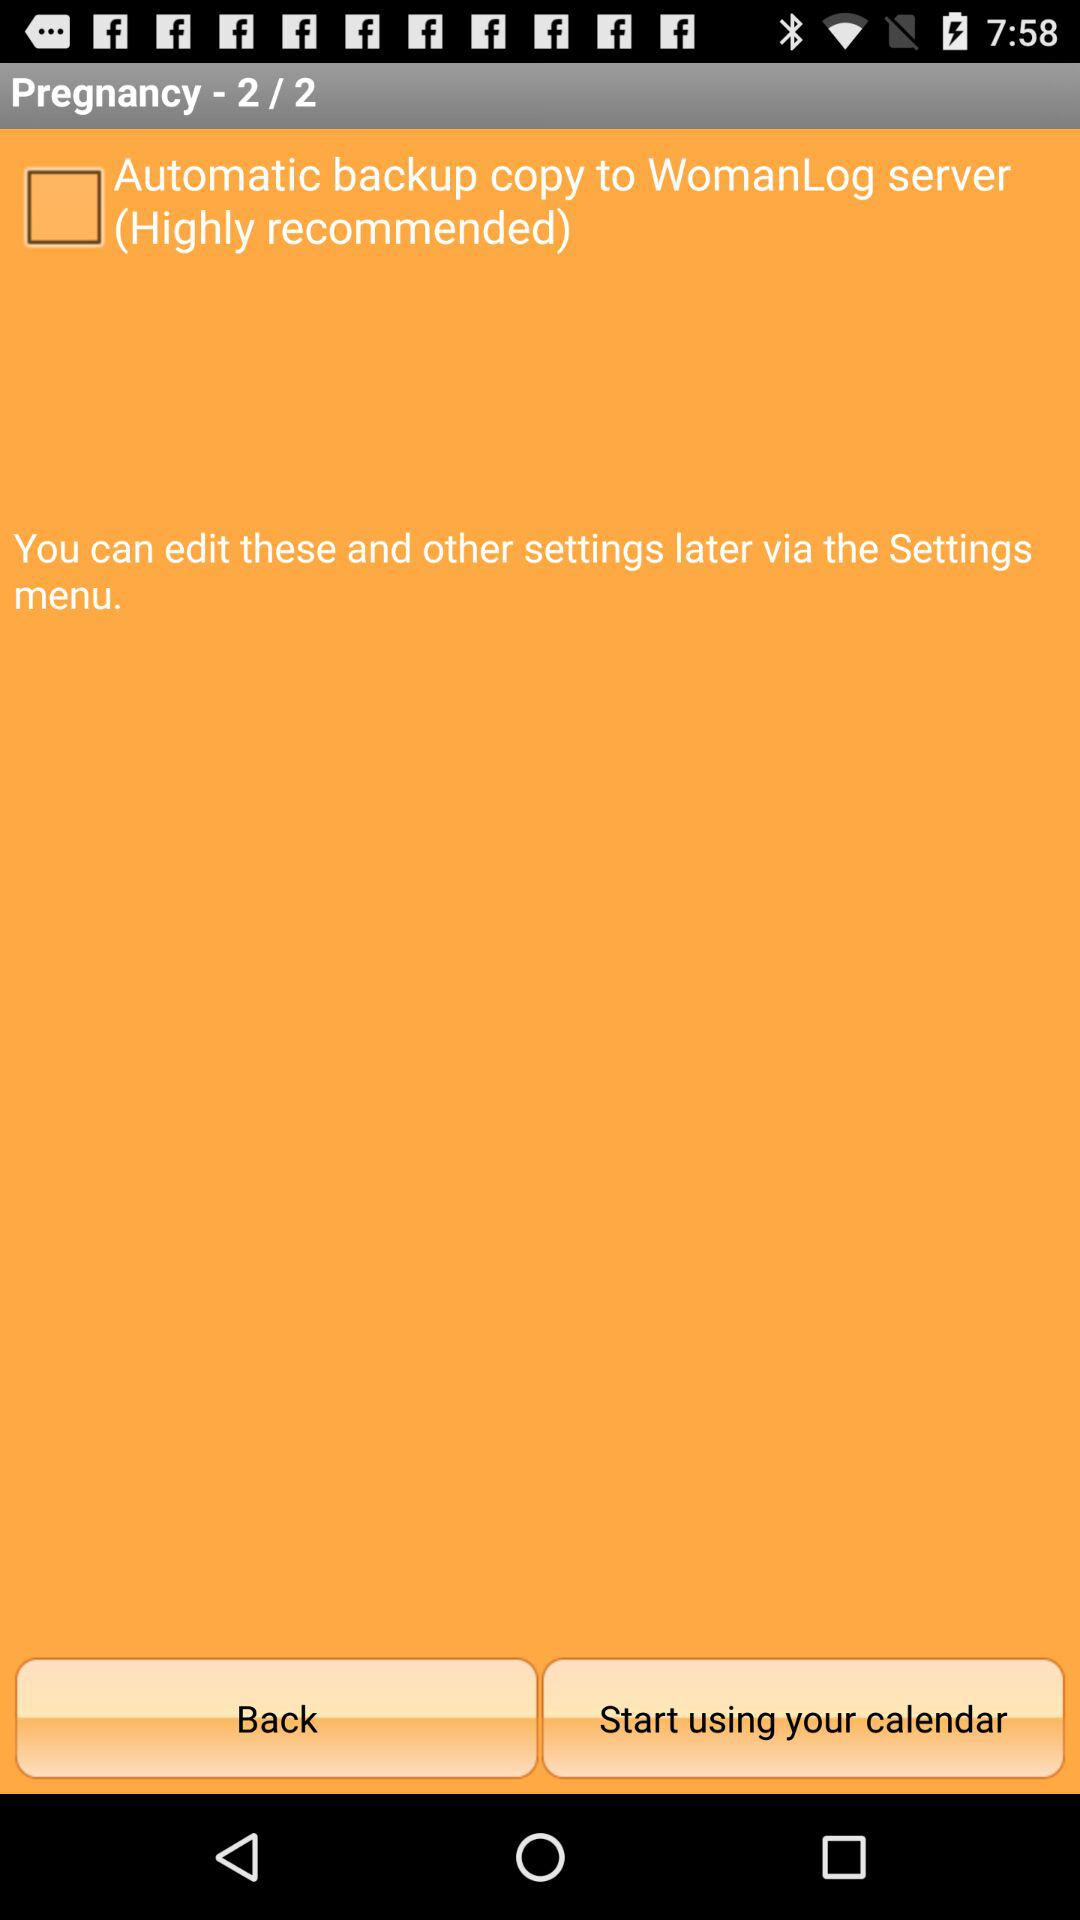What is the status of "Automatic backup copy to Woman Log server"? The status is "off". 